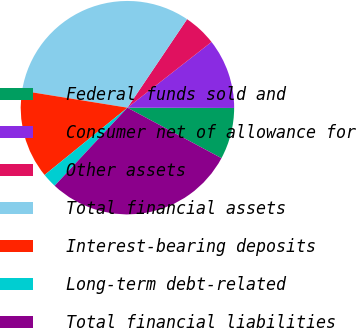<chart> <loc_0><loc_0><loc_500><loc_500><pie_chart><fcel>Federal funds sold and<fcel>Consumer net of allowance for<fcel>Other assets<fcel>Total financial assets<fcel>Interest-bearing deposits<fcel>Long-term debt-related<fcel>Total financial liabilities<nl><fcel>7.8%<fcel>10.6%<fcel>5.0%<fcel>31.9%<fcel>13.4%<fcel>2.2%<fcel>29.1%<nl></chart> 